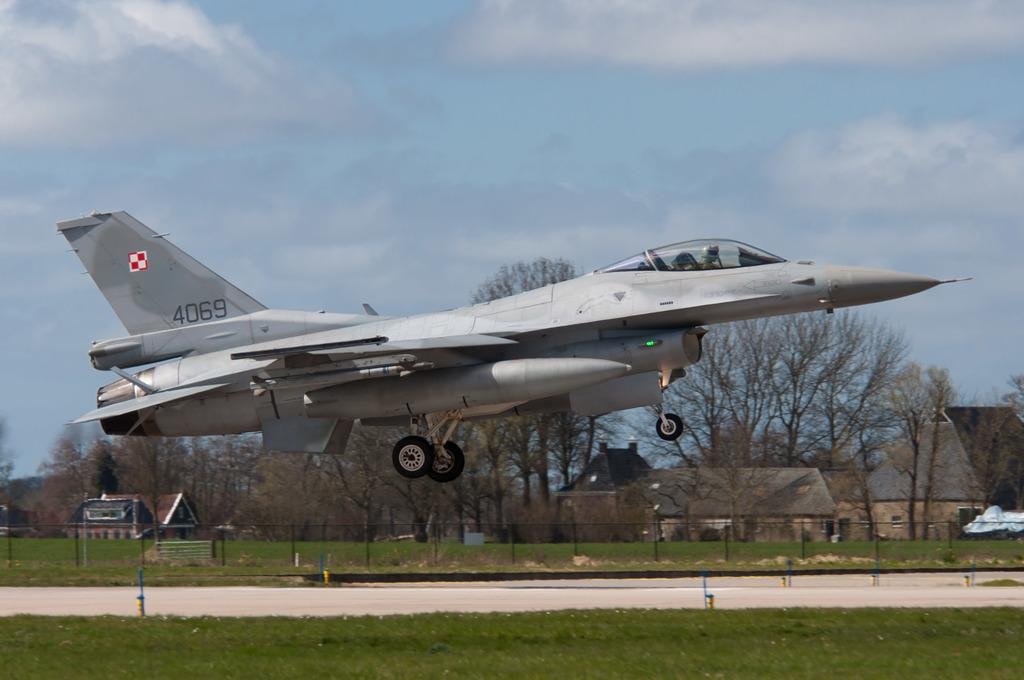What is flying in the sky in the image? There is an aeroplane flying in the sky in the image. What type of vegetation can be seen in the image? There is grass visible in the image. What is the purpose of the fencing in the image? The fencing in the image is likely used to define boundaries or enclose an area. What can be seen in the background of the image? There are trees and buildings in the background of the image. What is the income of the goose in the image? There is no goose present in the image, so it is not possible to determine its income. 